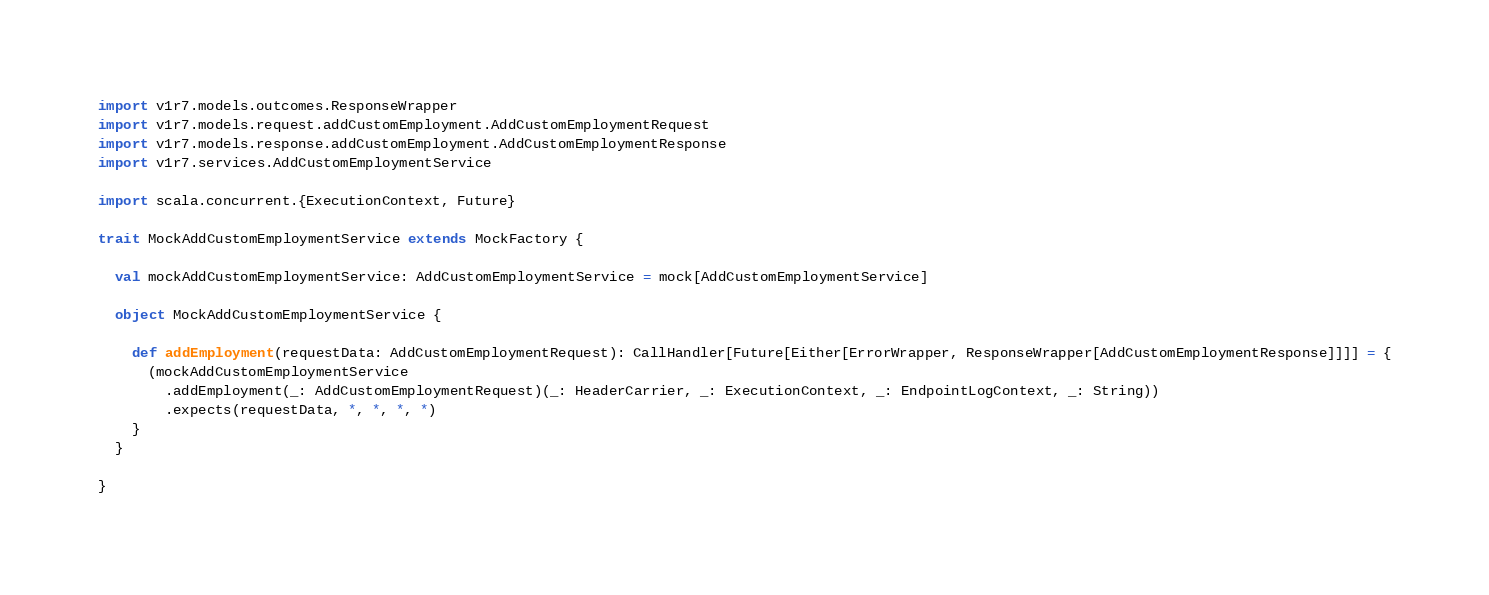<code> <loc_0><loc_0><loc_500><loc_500><_Scala_>import v1r7.models.outcomes.ResponseWrapper
import v1r7.models.request.addCustomEmployment.AddCustomEmploymentRequest
import v1r7.models.response.addCustomEmployment.AddCustomEmploymentResponse
import v1r7.services.AddCustomEmploymentService

import scala.concurrent.{ExecutionContext, Future}

trait MockAddCustomEmploymentService extends MockFactory {

  val mockAddCustomEmploymentService: AddCustomEmploymentService = mock[AddCustomEmploymentService]

  object MockAddCustomEmploymentService {

    def addEmployment(requestData: AddCustomEmploymentRequest): CallHandler[Future[Either[ErrorWrapper, ResponseWrapper[AddCustomEmploymentResponse]]]] = {
      (mockAddCustomEmploymentService
        .addEmployment(_: AddCustomEmploymentRequest)(_: HeaderCarrier, _: ExecutionContext, _: EndpointLogContext, _: String))
        .expects(requestData, *, *, *, *)
    }
  }

}</code> 